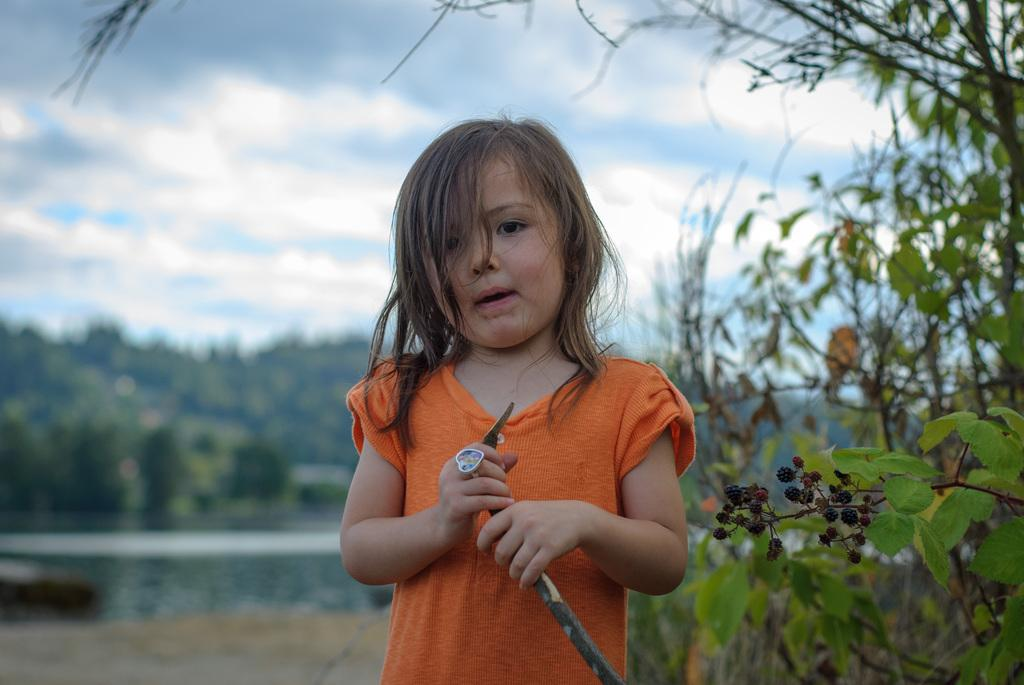Who is the main subject in the image? There is a girl in the center of the image. What is the girl holding in the image? The girl is holding a stick. What can be seen in the background of the image? There are trees in the background of the image. What is visible at the top of the image? The sky is visible at the top of the image. What can be observed in the sky? There are clouds in the sky. How many tin sheep are visible in the image? There are no tin sheep present in the image. 